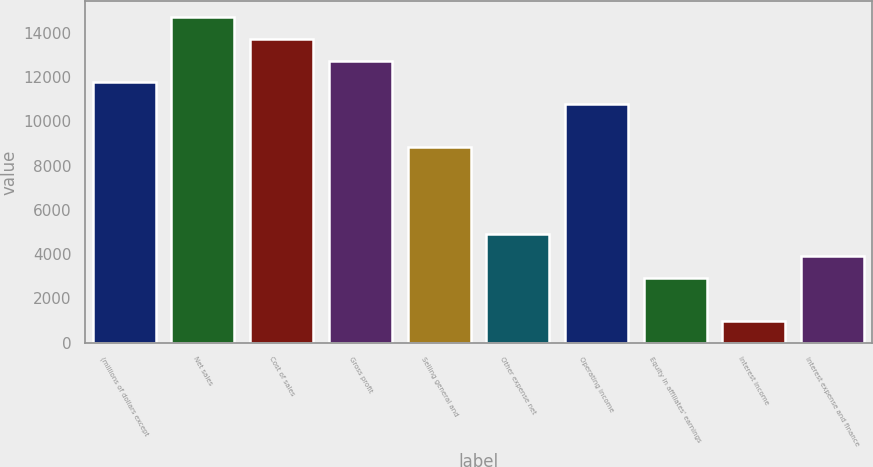Convert chart. <chart><loc_0><loc_0><loc_500><loc_500><bar_chart><fcel>(millions of dollars except<fcel>Net sales<fcel>Cost of sales<fcel>Gross profit<fcel>Selling general and<fcel>Other expense net<fcel>Operating income<fcel>Equity in affiliates' earnings<fcel>Interest income<fcel>Interest expense and finance<nl><fcel>11758.7<fcel>14697.9<fcel>13718.2<fcel>12738.4<fcel>8819.56<fcel>4900.68<fcel>10779<fcel>2941.24<fcel>981.8<fcel>3920.96<nl></chart> 